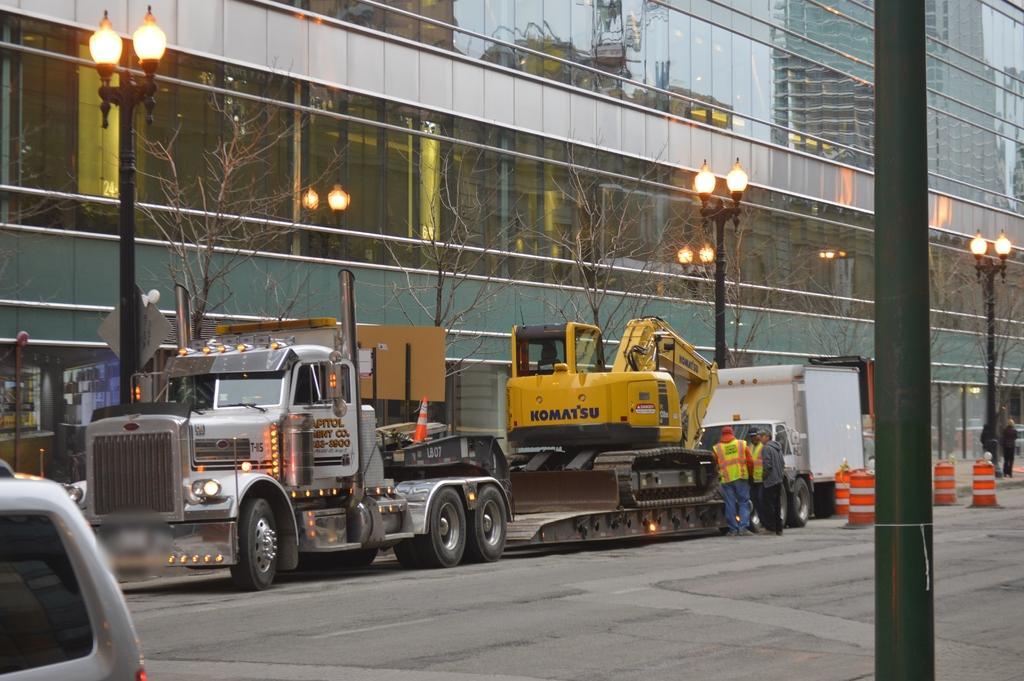Can you describe this image briefly? In this given picture, I can see a big building and electrical poles which includes lights and i can see few people after that a lorry, mini truck and a road. 